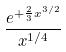Convert formula to latex. <formula><loc_0><loc_0><loc_500><loc_500>\frac { e ^ { + \frac { 2 } { 3 } x ^ { 3 / 2 } } } { x ^ { 1 / 4 } }</formula> 